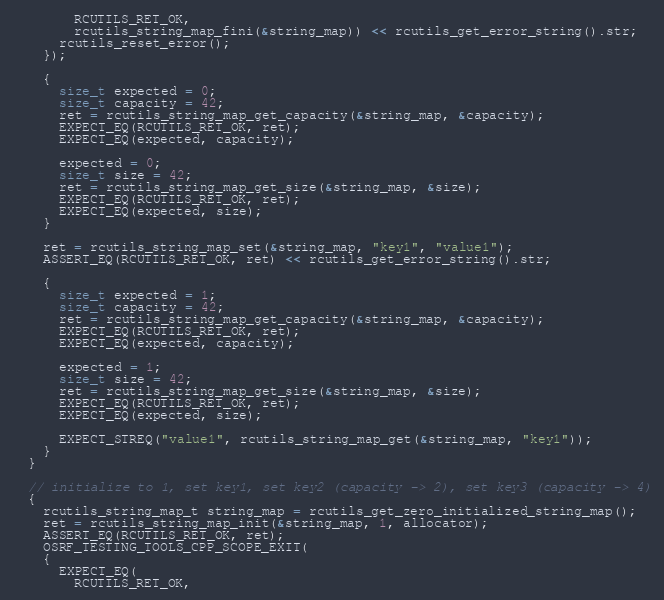<code> <loc_0><loc_0><loc_500><loc_500><_C++_>        RCUTILS_RET_OK,
        rcutils_string_map_fini(&string_map)) << rcutils_get_error_string().str;
      rcutils_reset_error();
    });

    {
      size_t expected = 0;
      size_t capacity = 42;
      ret = rcutils_string_map_get_capacity(&string_map, &capacity);
      EXPECT_EQ(RCUTILS_RET_OK, ret);
      EXPECT_EQ(expected, capacity);

      expected = 0;
      size_t size = 42;
      ret = rcutils_string_map_get_size(&string_map, &size);
      EXPECT_EQ(RCUTILS_RET_OK, ret);
      EXPECT_EQ(expected, size);
    }

    ret = rcutils_string_map_set(&string_map, "key1", "value1");
    ASSERT_EQ(RCUTILS_RET_OK, ret) << rcutils_get_error_string().str;

    {
      size_t expected = 1;
      size_t capacity = 42;
      ret = rcutils_string_map_get_capacity(&string_map, &capacity);
      EXPECT_EQ(RCUTILS_RET_OK, ret);
      EXPECT_EQ(expected, capacity);

      expected = 1;
      size_t size = 42;
      ret = rcutils_string_map_get_size(&string_map, &size);
      EXPECT_EQ(RCUTILS_RET_OK, ret);
      EXPECT_EQ(expected, size);

      EXPECT_STREQ("value1", rcutils_string_map_get(&string_map, "key1"));
    }
  }

  // initialize to 1, set key1, set key2 (capacity -> 2), set key3 (capacity -> 4)
  {
    rcutils_string_map_t string_map = rcutils_get_zero_initialized_string_map();
    ret = rcutils_string_map_init(&string_map, 1, allocator);
    ASSERT_EQ(RCUTILS_RET_OK, ret);
    OSRF_TESTING_TOOLS_CPP_SCOPE_EXIT(
    {
      EXPECT_EQ(
        RCUTILS_RET_OK,</code> 